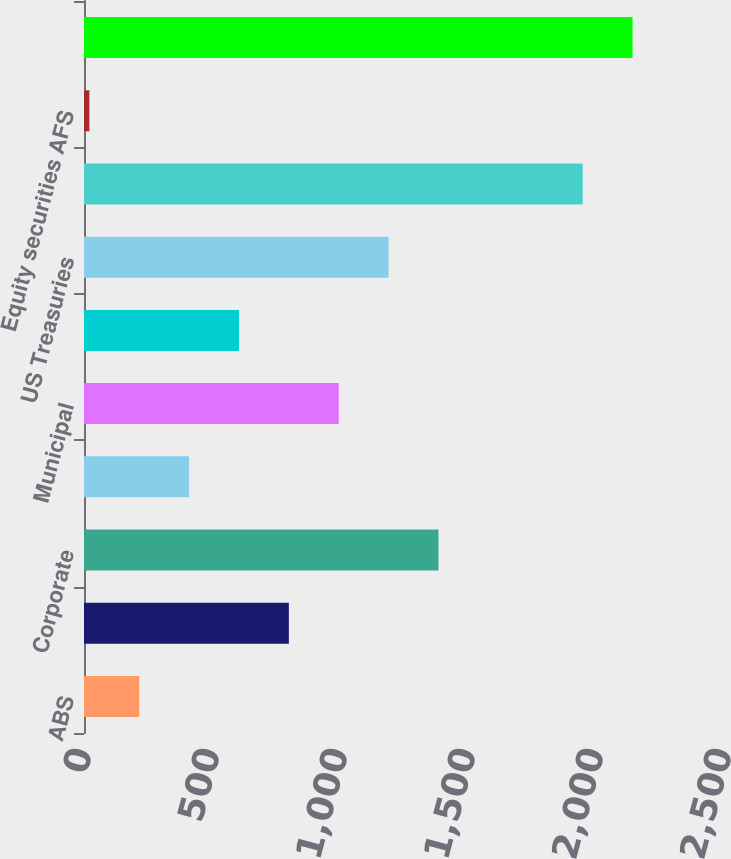<chart> <loc_0><loc_0><loc_500><loc_500><bar_chart><fcel>ABS<fcel>CMBS<fcel>Corporate<fcel>Foreign govt/govt agencies<fcel>Municipal<fcel>RMBS<fcel>US Treasuries<fcel>Total fixed maturities AFS<fcel>Equity securities AFS<fcel>Total securities in an<nl><fcel>215.8<fcel>800.2<fcel>1384.6<fcel>410.6<fcel>995<fcel>605.4<fcel>1189.8<fcel>1948<fcel>21<fcel>2142.8<nl></chart> 